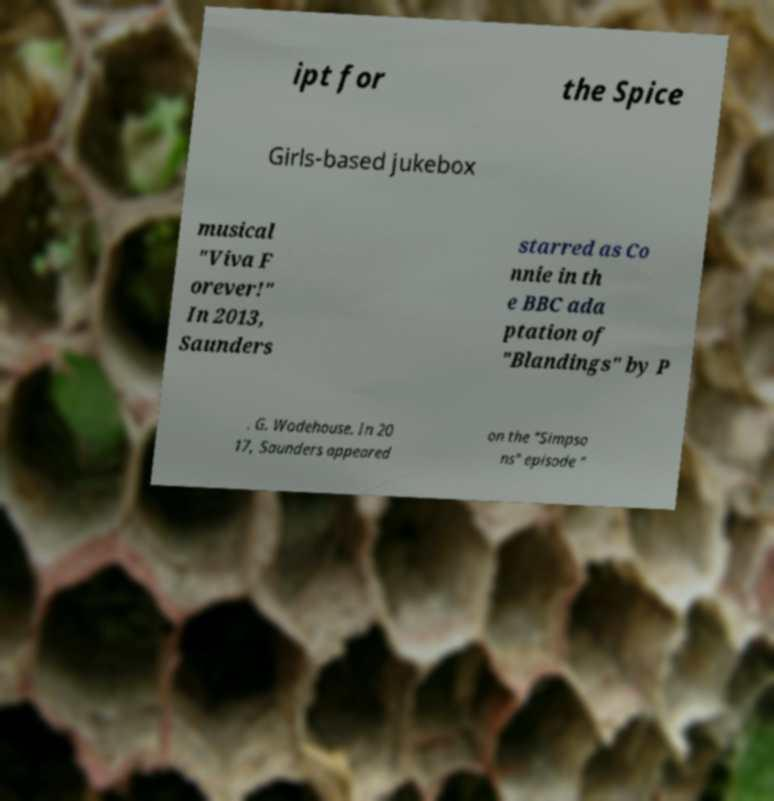There's text embedded in this image that I need extracted. Can you transcribe it verbatim? ipt for the Spice Girls-based jukebox musical "Viva F orever!" In 2013, Saunders starred as Co nnie in th e BBC ada ptation of "Blandings" by P . G. Wodehouse. In 20 17, Saunders appeared on the "Simpso ns" episode " 